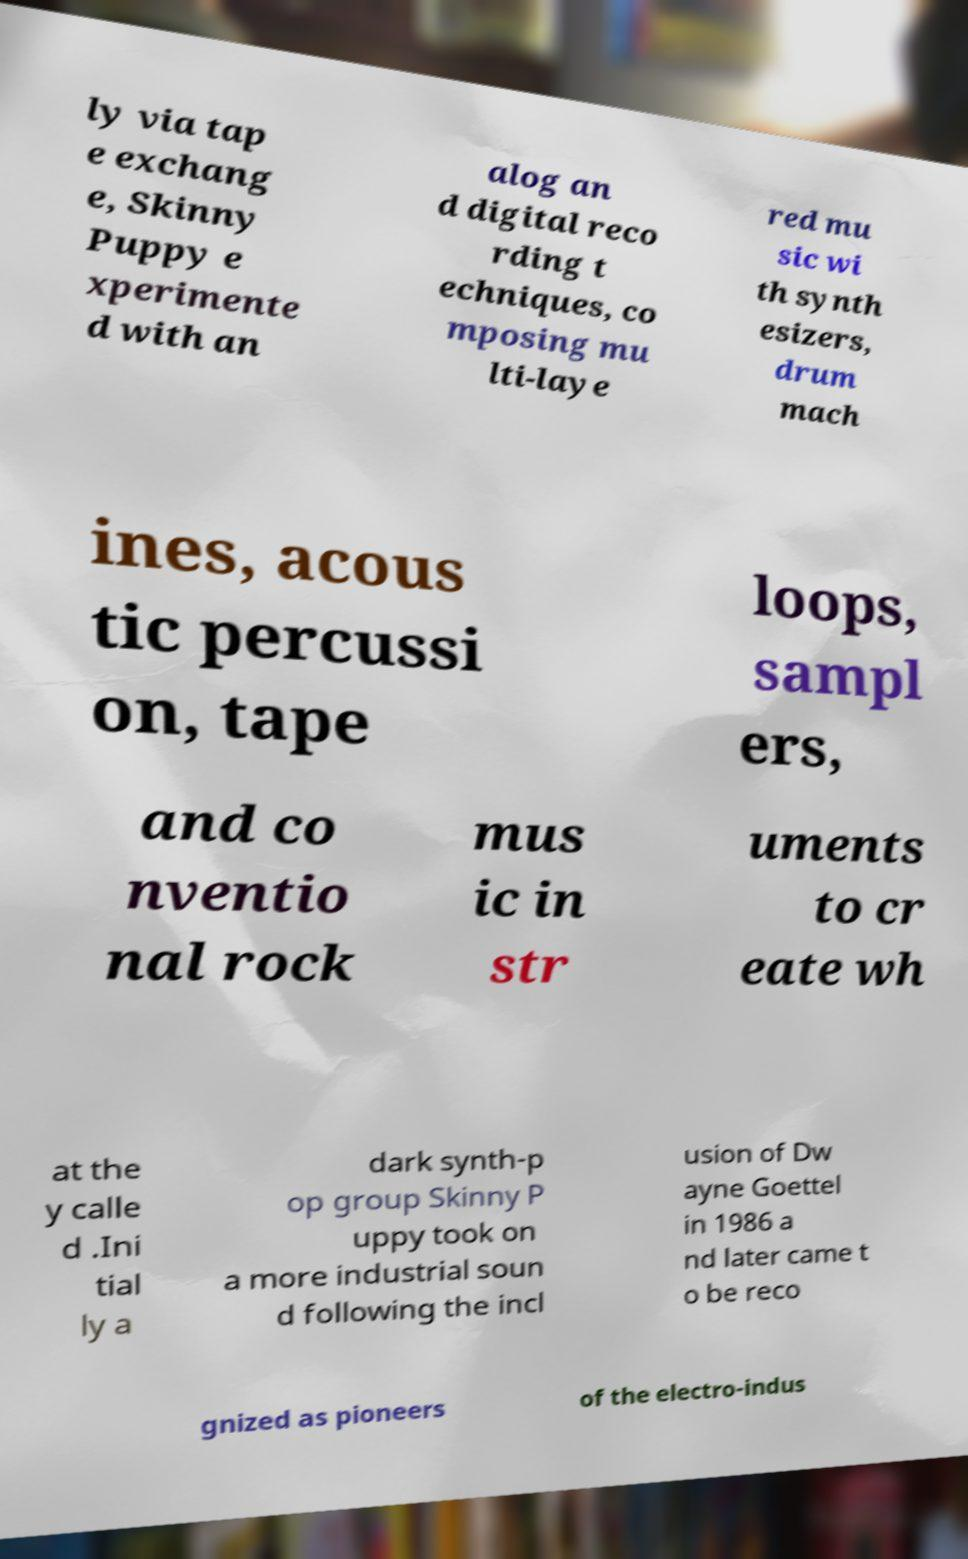Could you assist in decoding the text presented in this image and type it out clearly? ly via tap e exchang e, Skinny Puppy e xperimente d with an alog an d digital reco rding t echniques, co mposing mu lti-laye red mu sic wi th synth esizers, drum mach ines, acous tic percussi on, tape loops, sampl ers, and co nventio nal rock mus ic in str uments to cr eate wh at the y calle d .Ini tial ly a dark synth-p op group Skinny P uppy took on a more industrial soun d following the incl usion of Dw ayne Goettel in 1986 a nd later came t o be reco gnized as pioneers of the electro-indus 